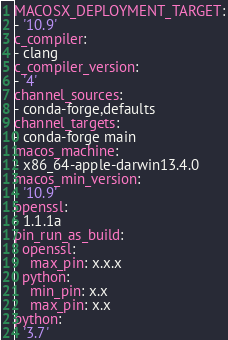<code> <loc_0><loc_0><loc_500><loc_500><_YAML_>MACOSX_DEPLOYMENT_TARGET:
- '10.9'
c_compiler:
- clang
c_compiler_version:
- '4'
channel_sources:
- conda-forge,defaults
channel_targets:
- conda-forge main
macos_machine:
- x86_64-apple-darwin13.4.0
macos_min_version:
- '10.9'
openssl:
- 1.1.1a
pin_run_as_build:
  openssl:
    max_pin: x.x.x
  python:
    min_pin: x.x
    max_pin: x.x
python:
- '3.7'
</code> 